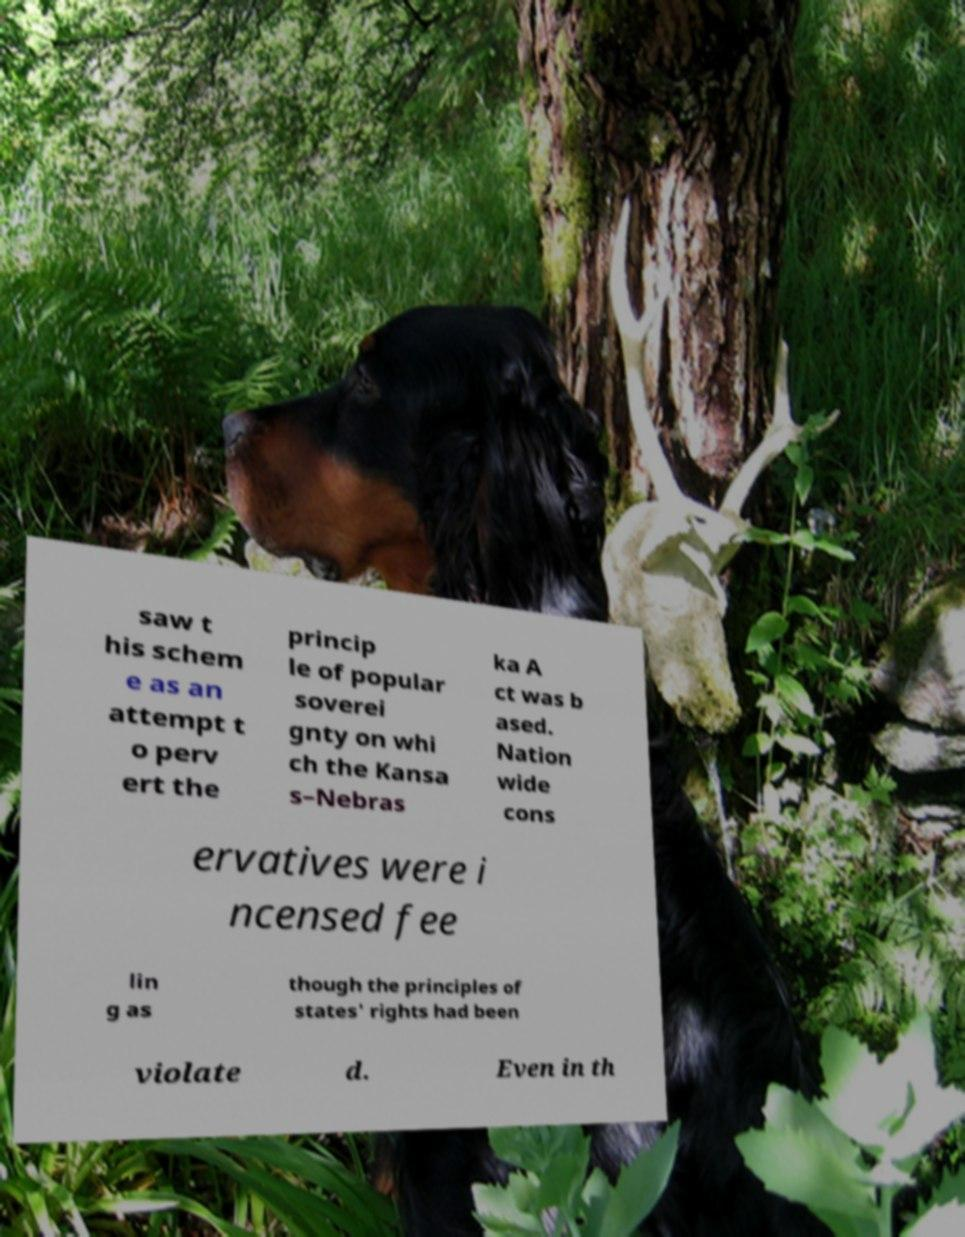Could you assist in decoding the text presented in this image and type it out clearly? saw t his schem e as an attempt t o perv ert the princip le of popular soverei gnty on whi ch the Kansa s–Nebras ka A ct was b ased. Nation wide cons ervatives were i ncensed fee lin g as though the principles of states' rights had been violate d. Even in th 